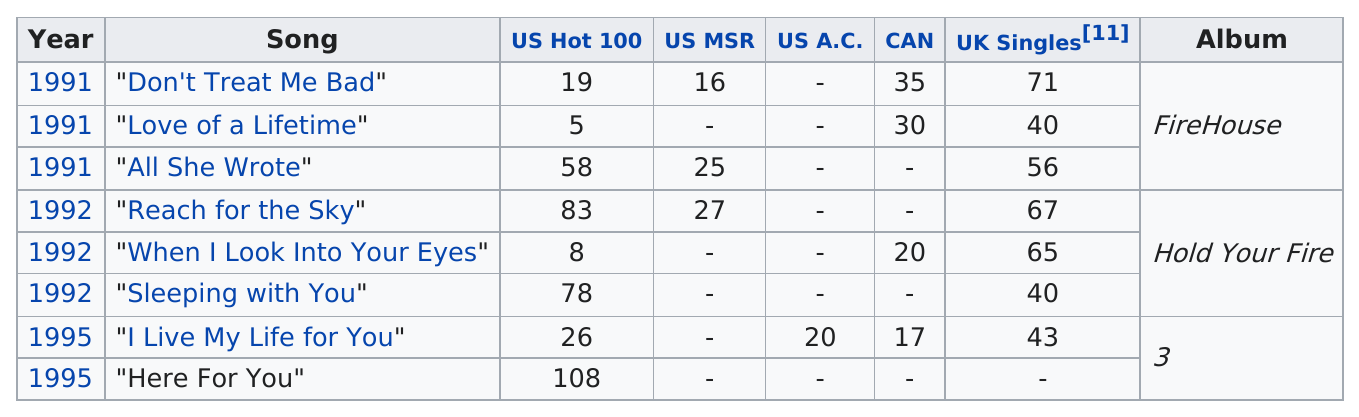Draw attention to some important aspects in this diagram. The first song to reach the top ten of the US Hot 100 list was 'Love of a Lifetime.' The band released a single called "Reach for the Sky" after the album "All She Wrote. The number of singles from the "Hold Your Fire" album was three. I, [name], declare that the last single that was released was 'Here For You'. Firehouse released their last single in the year 1995. 